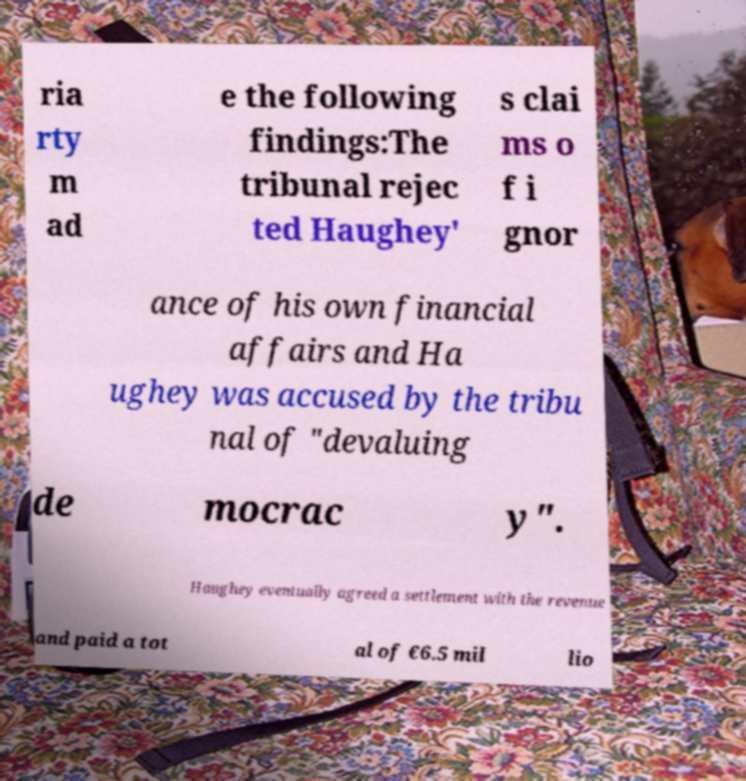Could you extract and type out the text from this image? ria rty m ad e the following findings:The tribunal rejec ted Haughey' s clai ms o f i gnor ance of his own financial affairs and Ha ughey was accused by the tribu nal of "devaluing de mocrac y". Haughey eventually agreed a settlement with the revenue and paid a tot al of €6.5 mil lio 